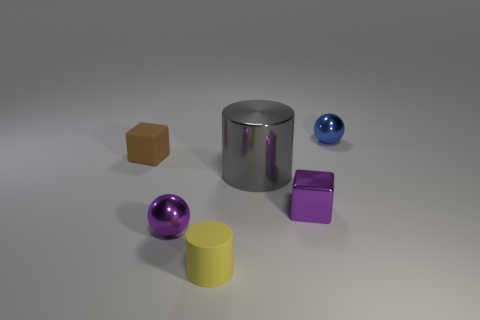Add 2 small matte cylinders. How many objects exist? 8 Subtract all spheres. How many objects are left? 4 Add 1 big cylinders. How many big cylinders are left? 2 Add 2 tiny balls. How many tiny balls exist? 4 Subtract 0 green blocks. How many objects are left? 6 Subtract all blue spheres. Subtract all tiny brown objects. How many objects are left? 4 